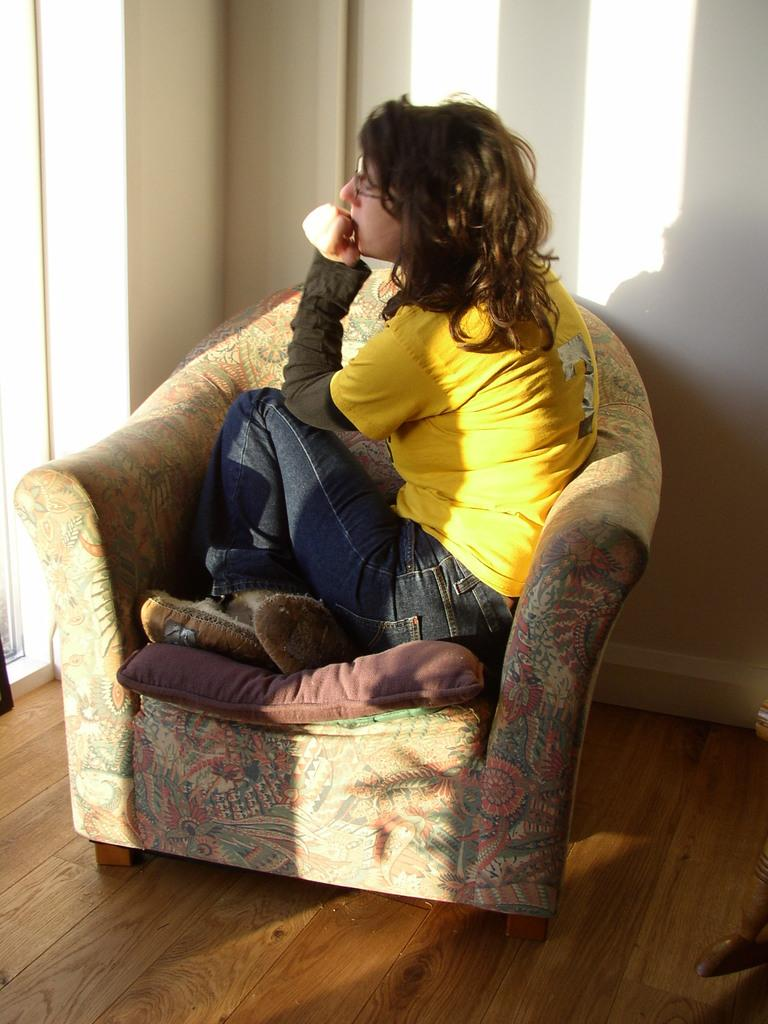Who or what is present in the image? There is a person in the image. What is the person doing in the image? The person is sitting on a chair. Can you describe the chair the person is sitting on? The chair has a cushion on it. What is visible in the background near the person? There is a wall near the person. What type of order is the fireman giving in the image? There is no fireman or order present in the image; it only features a person sitting on a chair with a cushion and a wall in the background. 